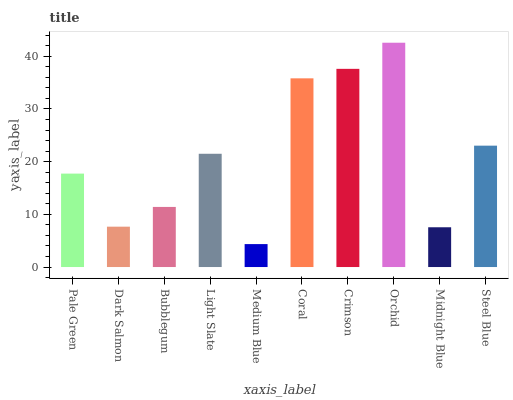Is Medium Blue the minimum?
Answer yes or no. Yes. Is Orchid the maximum?
Answer yes or no. Yes. Is Dark Salmon the minimum?
Answer yes or no. No. Is Dark Salmon the maximum?
Answer yes or no. No. Is Pale Green greater than Dark Salmon?
Answer yes or no. Yes. Is Dark Salmon less than Pale Green?
Answer yes or no. Yes. Is Dark Salmon greater than Pale Green?
Answer yes or no. No. Is Pale Green less than Dark Salmon?
Answer yes or no. No. Is Light Slate the high median?
Answer yes or no. Yes. Is Pale Green the low median?
Answer yes or no. Yes. Is Midnight Blue the high median?
Answer yes or no. No. Is Bubblegum the low median?
Answer yes or no. No. 